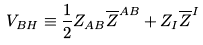<formula> <loc_0><loc_0><loc_500><loc_500>V _ { B H } \equiv \frac { 1 } { 2 } Z _ { A B } \overline { Z } ^ { A B } + Z _ { I } \overline { Z } ^ { I }</formula> 